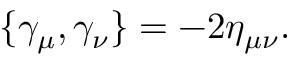Convert formula to latex. <formula><loc_0><loc_0><loc_500><loc_500>\{ \gamma _ { \mu } , \gamma _ { \nu } \} = - 2 \eta _ { \mu \nu } .</formula> 